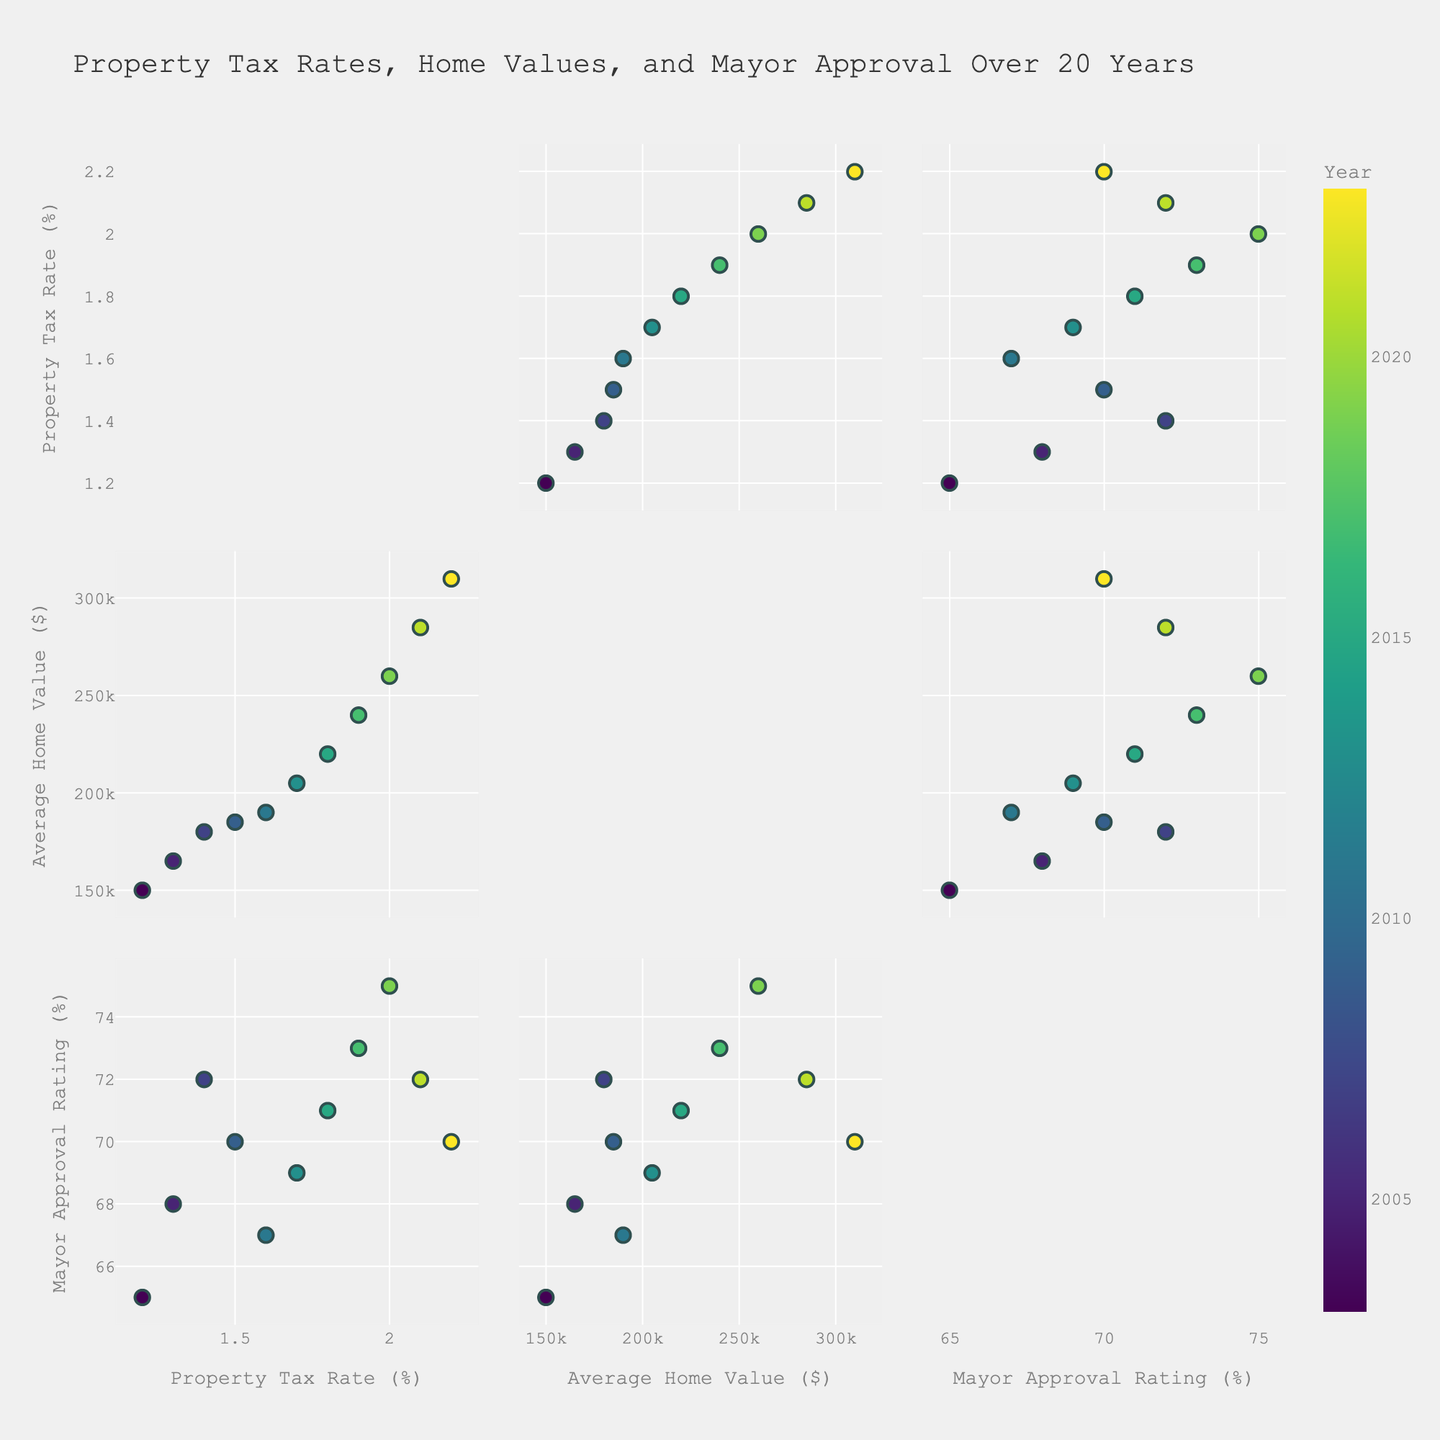What is the title of the figure? The title is usually situated at the top of the figure. In this plot, it indicates the purpose of the visualization.
Answer: Property Tax Rates, Home Values, and Mayor Approval Over 20 Years How many variables are included in the scatterplot matrix? A scatterplot matrix usually displays relationships between multiple variables. By checking the labels and axes, we can identify the number of variables.
Answer: Three What are the labels of the axes in the scatterplot matrix? The labels are shown along the horizontal and vertical axes of the plots. They define what each dimension represents.
Answer: Property Tax Rate (%), Average Home Value ($), Mayor Approval Rating (%) Which year had the highest average home value? By looking at the data points and their hover data, one can identify which year corresponds to the highest value on the Average Home Value axis.
Answer: 2023 Is there a general upward trend in property tax rates over the years? Observing the position of data points along the Property Tax Rate axis, one can determine if the values increase as the years progress.
Answer: Yes Do home values increase as property tax rates increase? By examining the scatter plots of Property Tax Rate versus Average Home Value, we can identify if there is a positive correlation between them.
Answer: Yes Which year had the highest mayoral approval rating? By checking the data points that reflect the Mayor Approval Rating axis and referring to the hover data, we identify the corresponding year.
Answer: 2019 How does the mayoral approval rating change relative to the average home value? By examining the scatter plots of Mayor Approval Rating versus Average Home Value, we can identify if there's a discernible trend or correlation.
Answer: Generally, it increases What is the relationship between property tax rates and mayoral approval ratings? By studying the scatter plots of Property Tax Rate versus Mayor Approval Rating, we can infer if an increase in property tax rates impacts mayoral approval.
Answer: Mixed relationship 